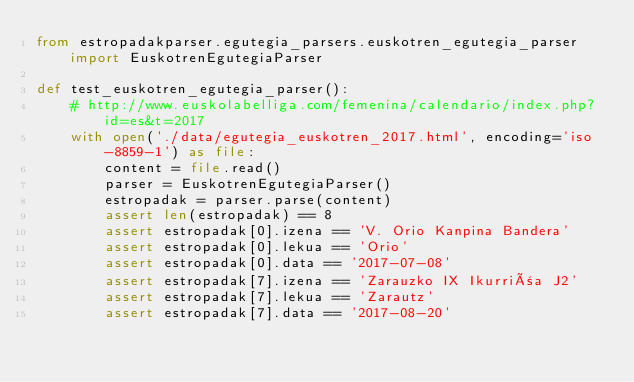<code> <loc_0><loc_0><loc_500><loc_500><_Python_>from estropadakparser.egutegia_parsers.euskotren_egutegia_parser import EuskotrenEgutegiaParser

def test_euskotren_egutegia_parser():
    # http://www.euskolabelliga.com/femenina/calendario/index.php?id=es&t=2017
    with open('./data/egutegia_euskotren_2017.html', encoding='iso-8859-1') as file:
        content = file.read()
        parser = EuskotrenEgutegiaParser()
        estropadak = parser.parse(content)
        assert len(estropadak) == 8
        assert estropadak[0].izena == 'V. Orio Kanpina Bandera'
        assert estropadak[0].lekua == 'Orio'
        assert estropadak[0].data == '2017-07-08'
        assert estropadak[7].izena == 'Zarauzko IX Ikurriña J2'
        assert estropadak[7].lekua == 'Zarautz'
        assert estropadak[7].data == '2017-08-20'
</code> 